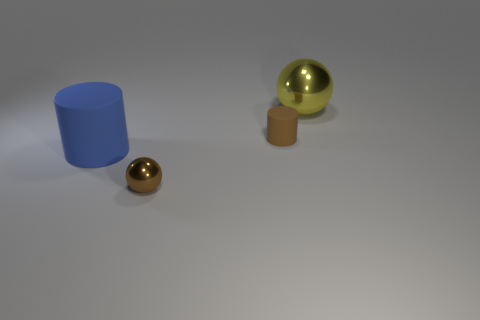There is a cylinder that is behind the blue cylinder; does it have the same size as the brown metal ball?
Offer a very short reply. Yes. There is a blue rubber cylinder that is on the left side of the cylinder that is behind the large blue thing; how many yellow metal spheres are to the left of it?
Your answer should be compact. 0. What number of purple things are matte cylinders or small rubber things?
Give a very brief answer. 0. The other object that is the same material as the large yellow thing is what color?
Your response must be concise. Brown. Is there anything else that has the same size as the blue cylinder?
Provide a succinct answer. Yes. How many tiny things are yellow metal things or red metallic cylinders?
Your answer should be compact. 0. Are there fewer big yellow shiny things than blue shiny objects?
Provide a succinct answer. No. The other small rubber object that is the same shape as the blue thing is what color?
Ensure brevity in your answer.  Brown. Is the number of big yellow balls greater than the number of big gray blocks?
Ensure brevity in your answer.  Yes. What number of other objects are the same material as the big yellow object?
Your answer should be compact. 1. 